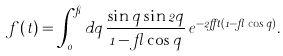Convert formula to latex. <formula><loc_0><loc_0><loc_500><loc_500>f ( t ) = \int _ { 0 } ^ { \pi } d q \, \frac { \sin q \sin 2 q } { 1 - \gamma \cos q } \, e ^ { - 2 \alpha t ( 1 - \gamma \cos q ) } .</formula> 